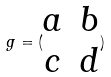<formula> <loc_0><loc_0><loc_500><loc_500>g = ( \begin{matrix} a & b \\ c & d \end{matrix} )</formula> 